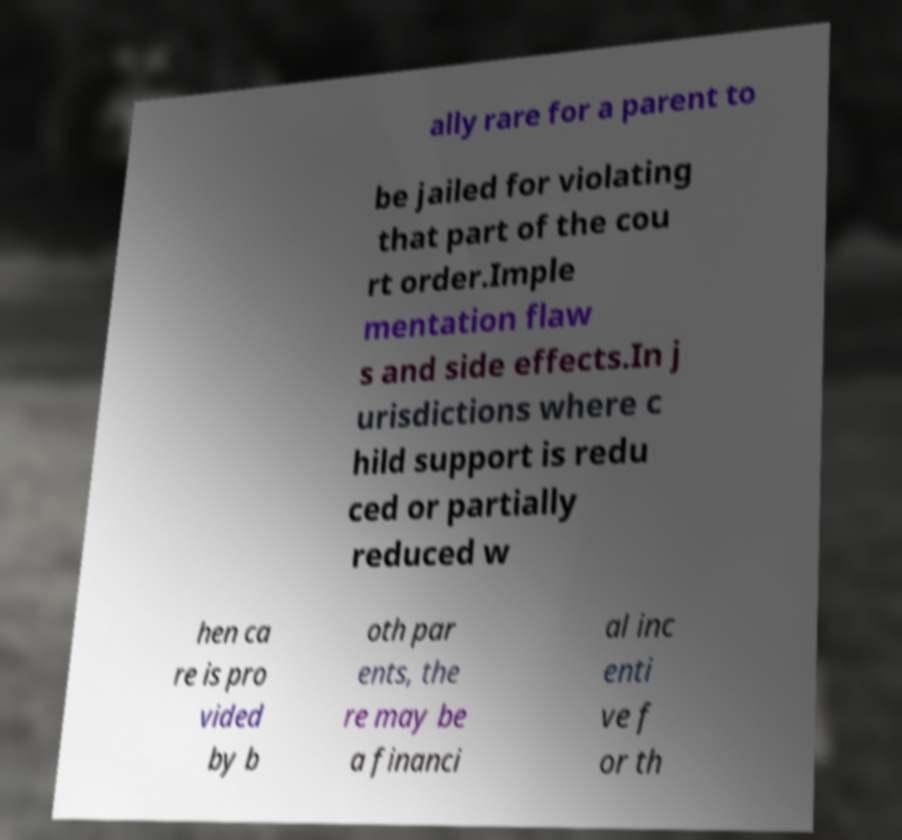Please identify and transcribe the text found in this image. ally rare for a parent to be jailed for violating that part of the cou rt order.Imple mentation flaw s and side effects.In j urisdictions where c hild support is redu ced or partially reduced w hen ca re is pro vided by b oth par ents, the re may be a financi al inc enti ve f or th 